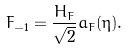<formula> <loc_0><loc_0><loc_500><loc_500>F _ { - 1 } = \frac { H _ { F } } { \sqrt { 2 } } a _ { F } ( \eta ) .</formula> 